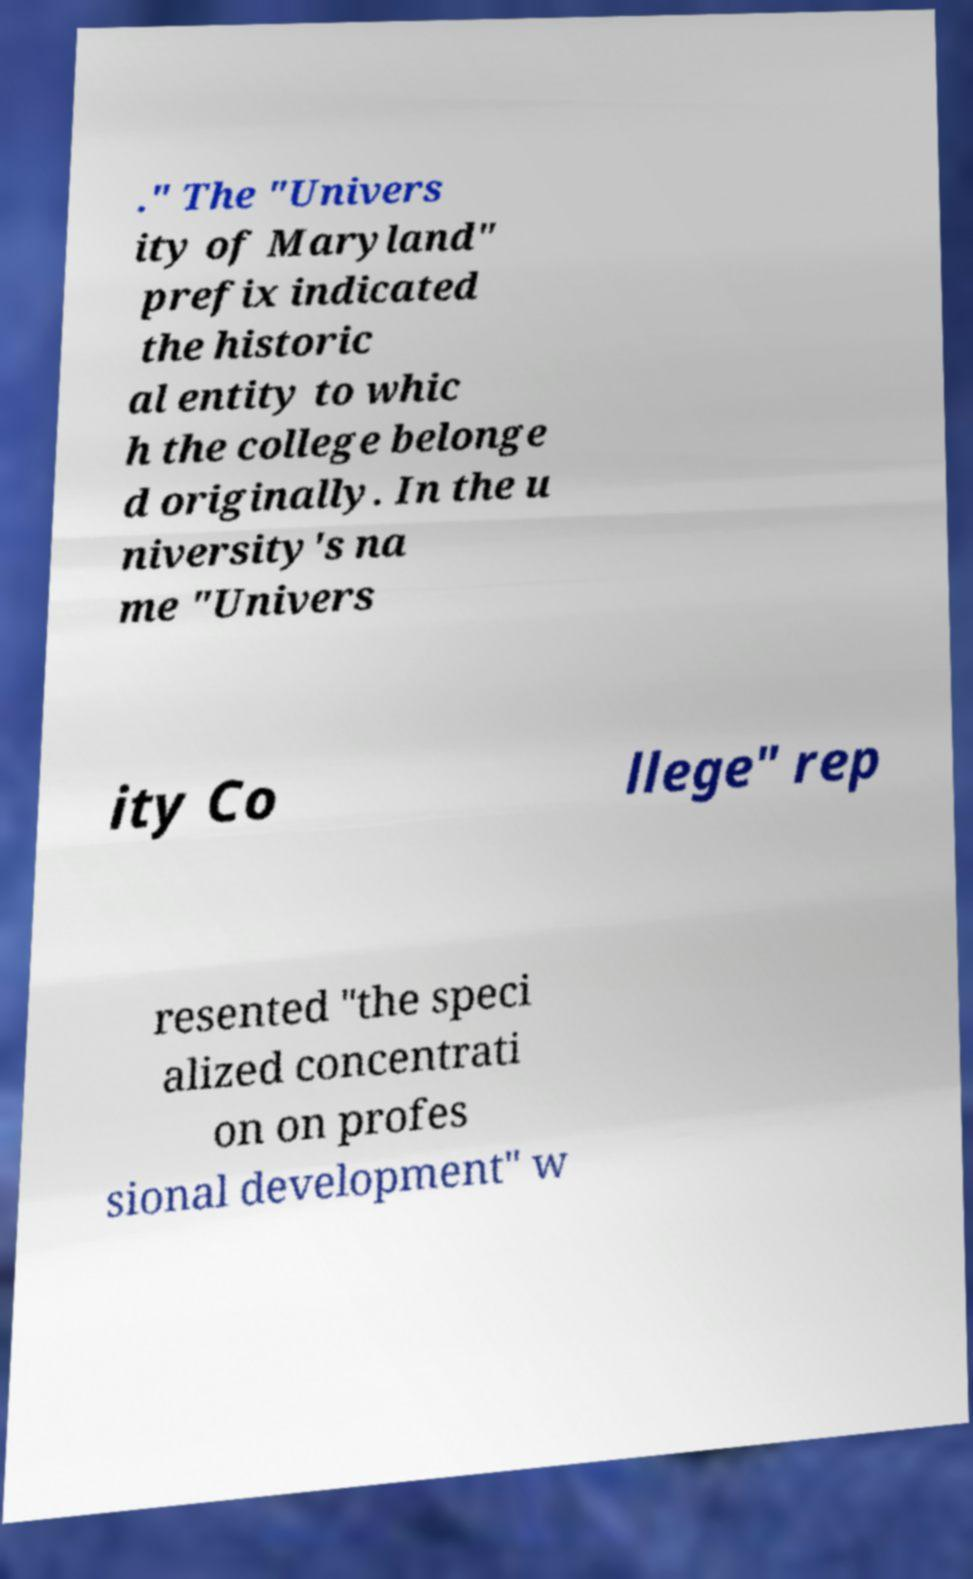Please read and relay the text visible in this image. What does it say? ." The "Univers ity of Maryland" prefix indicated the historic al entity to whic h the college belonge d originally. In the u niversity's na me "Univers ity Co llege" rep resented "the speci alized concentrati on on profes sional development" w 